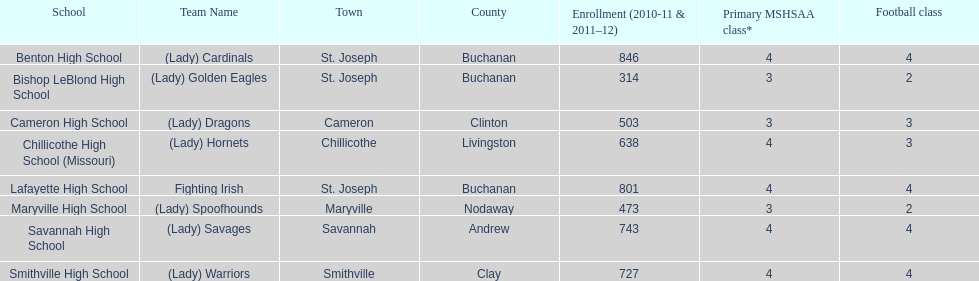What is the minimum number of students registered at a school mentioned here? 314. Which school has an enrollment of 314 students? Bishop LeBlond High School. 